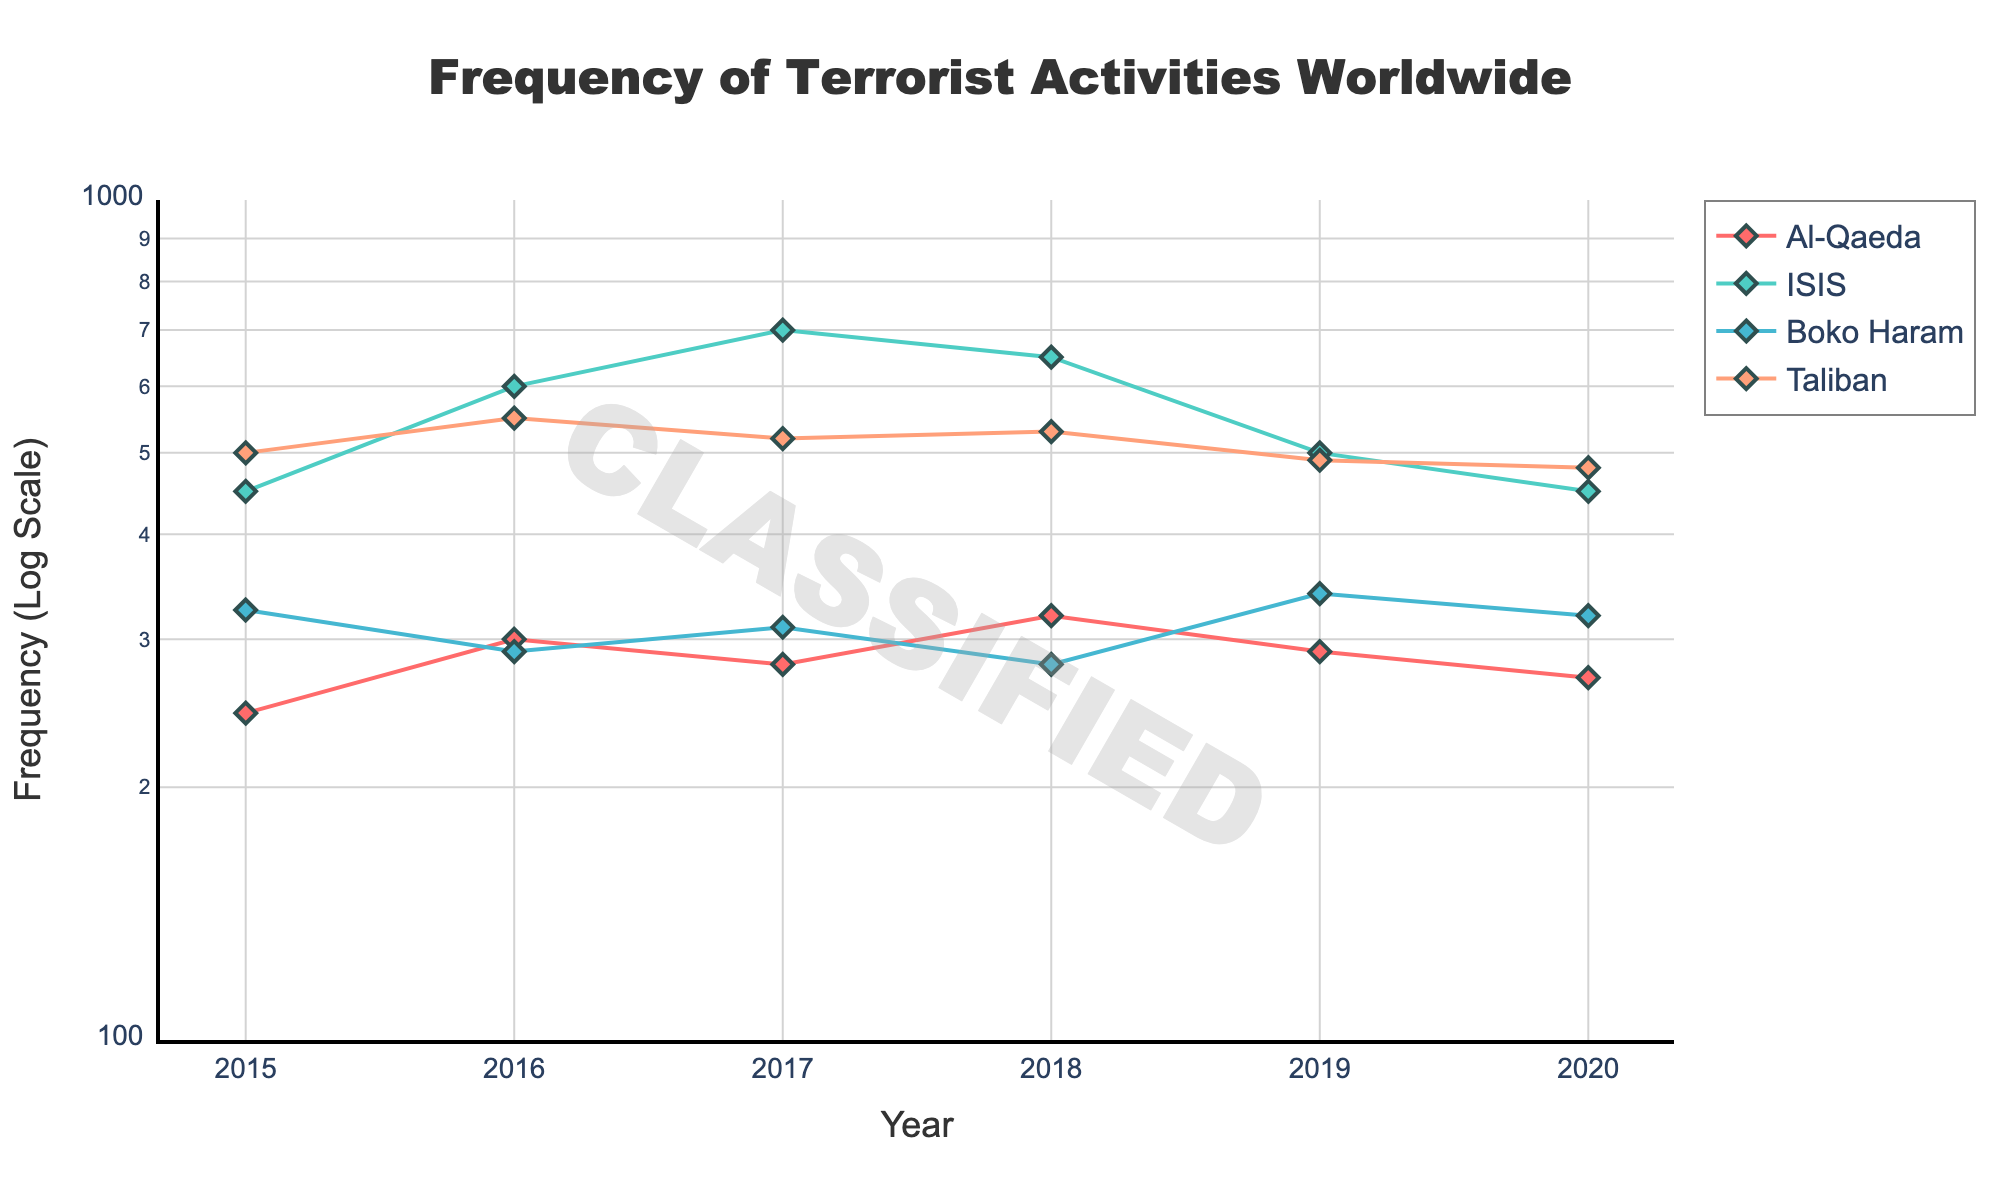What is the title of the figure? The title is prominently displayed at the top of the figure.
Answer: Frequency of Terrorist Activities Worldwide What is the range of the y-axis in the figure? The y-axis is labeled with a log scale and ranges from the log value of 100 (2) to the log value of 1000 (3).
Answer: Logarithmic scale from 100 to 1000 Which terrorist organization had the highest frequency of activities in 2017? By examining the figure, the line for ISIS in 2017 is at the highest point compared to other organizations.
Answer: ISIS How does the frequency of Boko Haram's activities in 2015 compare to 2019? Check the figure data points for Boko Haram in 2015 and 2019; 2015 is lower than 2019.
Answer: Increased What trend can be observed for Al-Qaeda activities from 2015 to 2020? The figure shows Al-Qaeda’s frequency generally decreasing over these years.
Answer: Decreasing trend Which organization had the most activities in 2016? Looking at the 2016 data points, the Taliban had the highest frequency.
Answer: Taliban How does the frequency of ISIS activities in 2019 compare to 2020? From the figure, ISIS activity in 2019 is higher than in 2020.
Answer: Decreased What could the y-axis type tell us about how data is represented in the figure? The log scale y-axis suggests that data values span a wide range and allows for easier comparison of multiplicative differences.
Answer: It represents data with wide-ranging values more clearly What is the color used for the Boko Haram line in the figure? The Boko Haram line can be identified by the color it’s drawn in, which is one of the four distinct colors used.
Answer: Light Steel Blue How do the frequency trends of ISIS and Taliban compare from 2015 to 2020? Both organizations exhibit fluctuations, but overall ISIS shows an increasing then decreasing trend, while Taliban maintains a high frequency with minor decreases.
Answer: ISIS: Increase then decrease, Taliban: slightly decreasing high frequency 